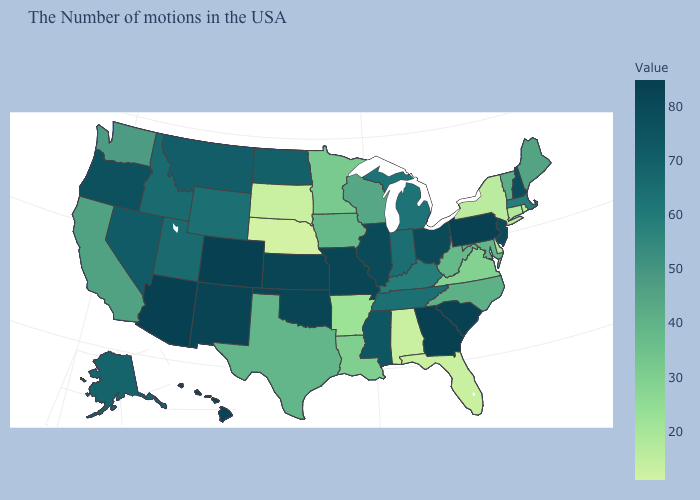Does Colorado have the highest value in the West?
Short answer required. Yes. Is the legend a continuous bar?
Short answer required. Yes. Is the legend a continuous bar?
Concise answer only. Yes. Which states have the highest value in the USA?
Concise answer only. Georgia, Colorado, Arizona. Does Nebraska have the lowest value in the USA?
Short answer required. Yes. Does New York have the lowest value in the Northeast?
Be succinct. Yes. 